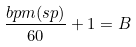Convert formula to latex. <formula><loc_0><loc_0><loc_500><loc_500>\frac { b p m ( s p ) } { 6 0 } + 1 = B</formula> 